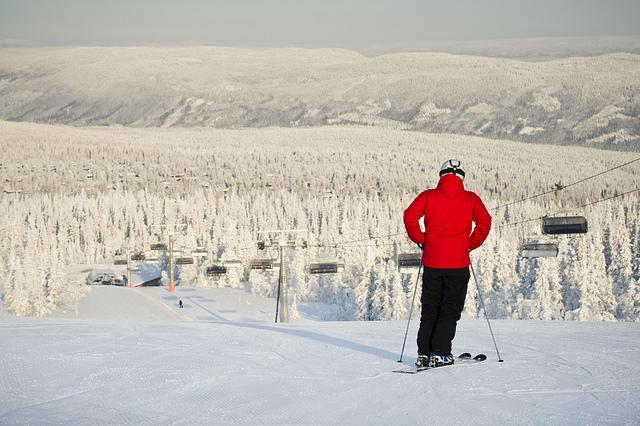What type of sport is he practicing? skiing 